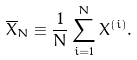Convert formula to latex. <formula><loc_0><loc_0><loc_500><loc_500>\overline { X } _ { N } \equiv \frac { 1 } { N } \sum _ { i = 1 } ^ { N } X ^ { ( i ) } .</formula> 